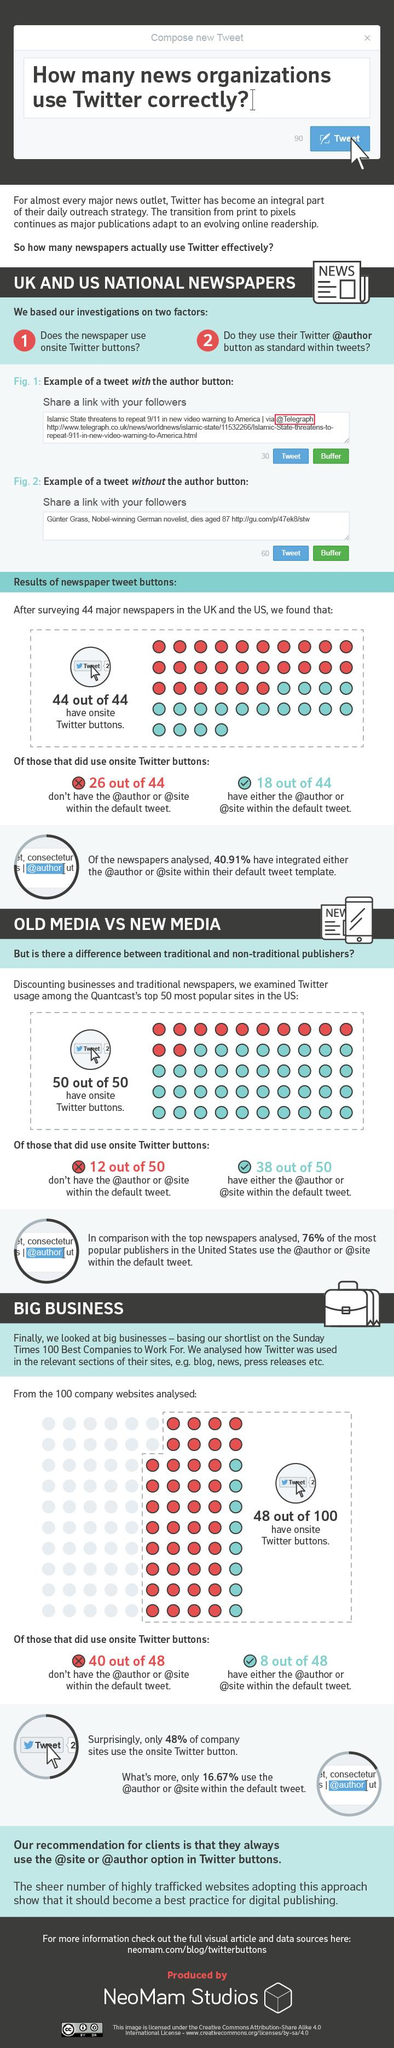Indicate a few pertinent items in this graphic. According to a recent study, a significant percentage of newspaper companies are not using the required hashtags in their tweets. Approximately 24% of media do not use required hashtags in their normal tweets. Approximately 52% of large businesses do not have an Onsite Twitter Button. According to a recent survey, 48% of giant business leaders use Twitter for their purpose and connection. The background color of the Tweet button is blue. 